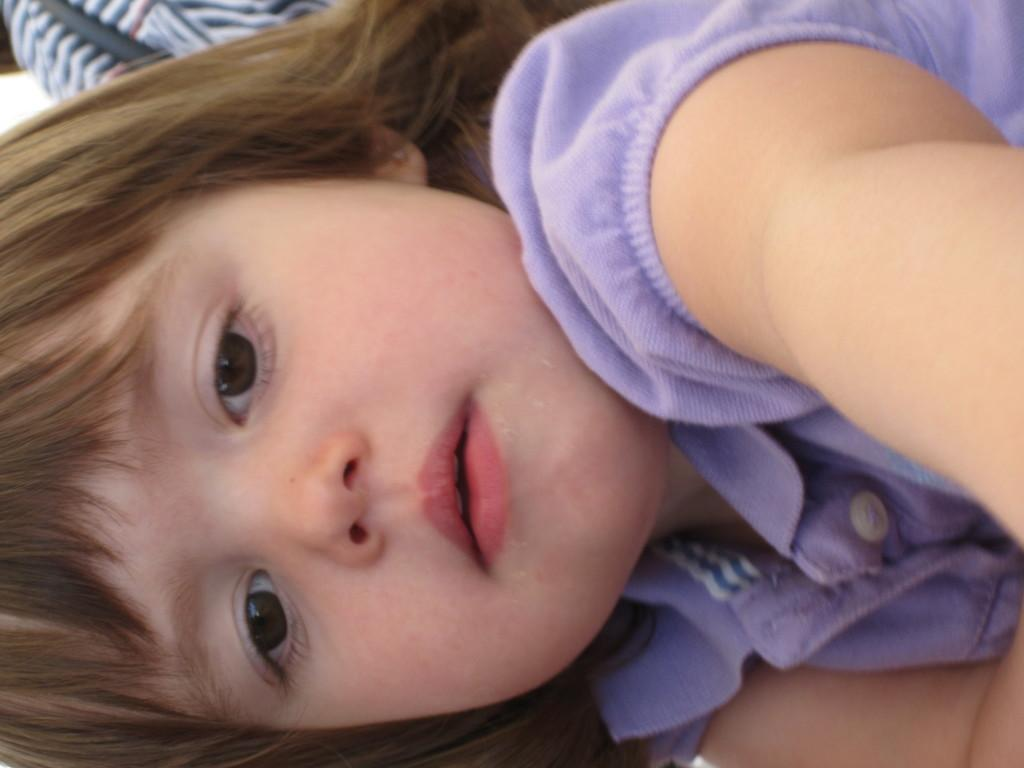Who is the main subject in the image? There is a girl in the image. Can you describe anything in the background of the image? There is an object in the background of the image. How many knees can be seen in the image? There is no visible knee in the image; it only shows a girl and an object in the background. 